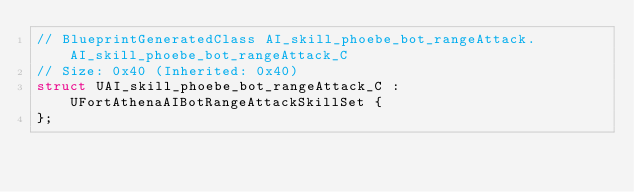<code> <loc_0><loc_0><loc_500><loc_500><_C_>// BlueprintGeneratedClass AI_skill_phoebe_bot_rangeAttack.AI_skill_phoebe_bot_rangeAttack_C
// Size: 0x40 (Inherited: 0x40)
struct UAI_skill_phoebe_bot_rangeAttack_C : UFortAthenaAIBotRangeAttackSkillSet {
};

</code> 